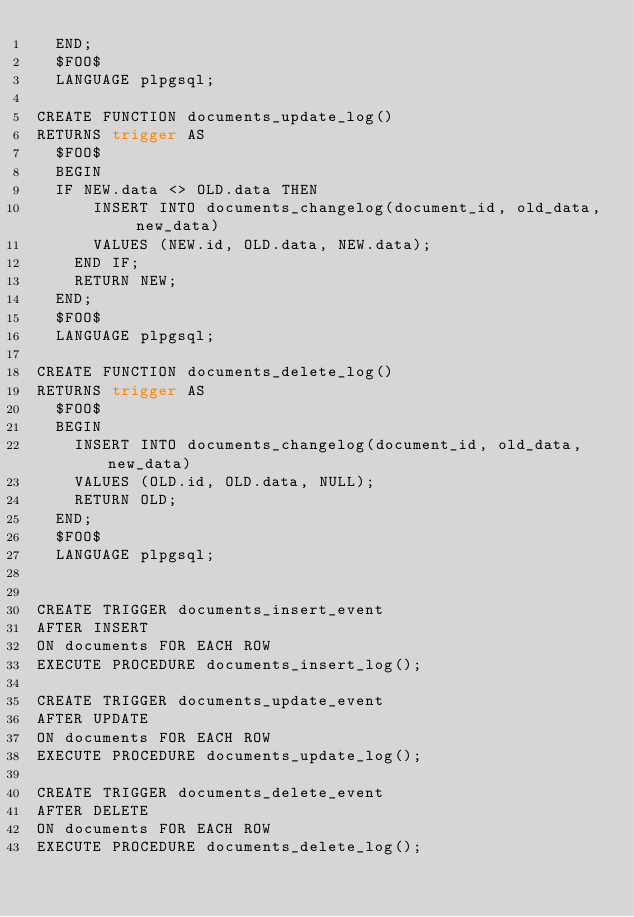Convert code to text. <code><loc_0><loc_0><loc_500><loc_500><_SQL_>  END;
  $FOO$
  LANGUAGE plpgsql;

CREATE FUNCTION documents_update_log()
RETURNS trigger AS
  $FOO$
  BEGIN
  IF NEW.data <> OLD.data THEN
      INSERT INTO documents_changelog(document_id, old_data, new_data)
      VALUES (NEW.id, OLD.data, NEW.data);
    END IF;
    RETURN NEW;
  END;
  $FOO$
  LANGUAGE plpgsql;

CREATE FUNCTION documents_delete_log()
RETURNS trigger AS
  $FOO$
  BEGIN
    INSERT INTO documents_changelog(document_id, old_data, new_data)
    VALUES (OLD.id, OLD.data, NULL);
    RETURN OLD;
  END;
  $FOO$
  LANGUAGE plpgsql;


CREATE TRIGGER documents_insert_event
AFTER INSERT
ON documents FOR EACH ROW
EXECUTE PROCEDURE documents_insert_log();

CREATE TRIGGER documents_update_event
AFTER UPDATE
ON documents FOR EACH ROW
EXECUTE PROCEDURE documents_update_log();

CREATE TRIGGER documents_delete_event
AFTER DELETE
ON documents FOR EACH ROW
EXECUTE PROCEDURE documents_delete_log();
</code> 